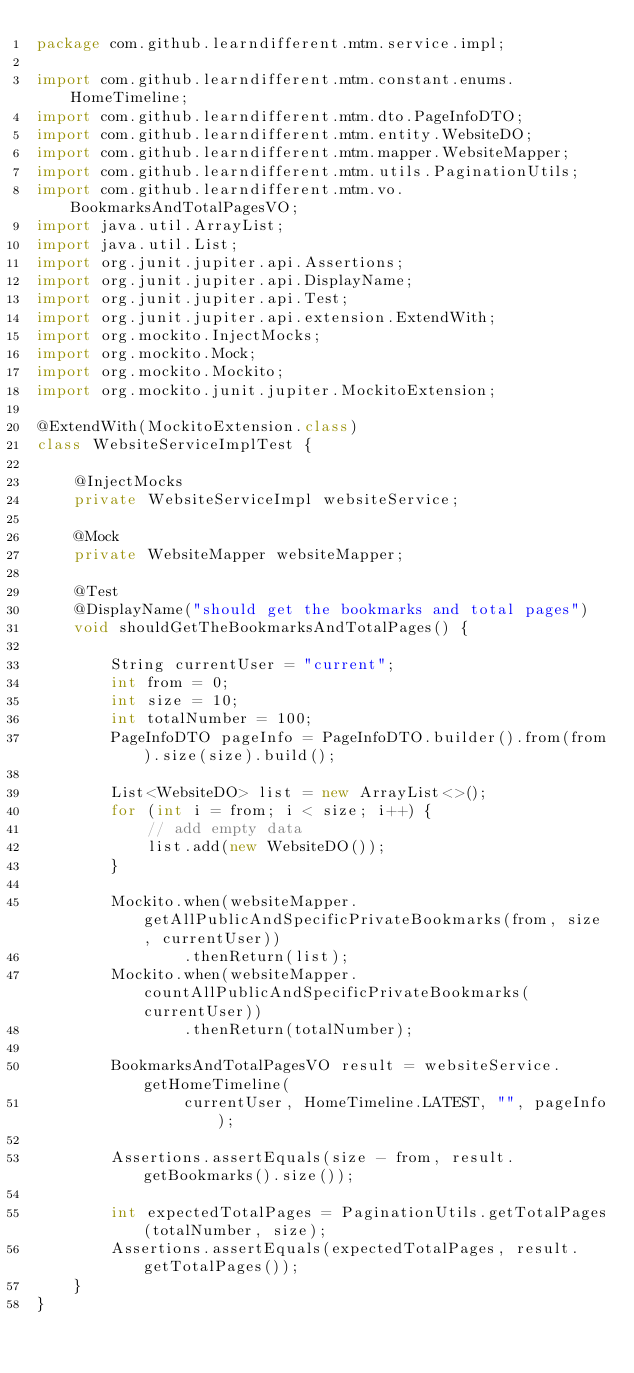Convert code to text. <code><loc_0><loc_0><loc_500><loc_500><_Java_>package com.github.learndifferent.mtm.service.impl;

import com.github.learndifferent.mtm.constant.enums.HomeTimeline;
import com.github.learndifferent.mtm.dto.PageInfoDTO;
import com.github.learndifferent.mtm.entity.WebsiteDO;
import com.github.learndifferent.mtm.mapper.WebsiteMapper;
import com.github.learndifferent.mtm.utils.PaginationUtils;
import com.github.learndifferent.mtm.vo.BookmarksAndTotalPagesVO;
import java.util.ArrayList;
import java.util.List;
import org.junit.jupiter.api.Assertions;
import org.junit.jupiter.api.DisplayName;
import org.junit.jupiter.api.Test;
import org.junit.jupiter.api.extension.ExtendWith;
import org.mockito.InjectMocks;
import org.mockito.Mock;
import org.mockito.Mockito;
import org.mockito.junit.jupiter.MockitoExtension;

@ExtendWith(MockitoExtension.class)
class WebsiteServiceImplTest {

    @InjectMocks
    private WebsiteServiceImpl websiteService;

    @Mock
    private WebsiteMapper websiteMapper;

    @Test
    @DisplayName("should get the bookmarks and total pages")
    void shouldGetTheBookmarksAndTotalPages() {

        String currentUser = "current";
        int from = 0;
        int size = 10;
        int totalNumber = 100;
        PageInfoDTO pageInfo = PageInfoDTO.builder().from(from).size(size).build();

        List<WebsiteDO> list = new ArrayList<>();
        for (int i = from; i < size; i++) {
            // add empty data
            list.add(new WebsiteDO());
        }

        Mockito.when(websiteMapper.getAllPublicAndSpecificPrivateBookmarks(from, size, currentUser))
                .thenReturn(list);
        Mockito.when(websiteMapper.countAllPublicAndSpecificPrivateBookmarks(currentUser))
                .thenReturn(totalNumber);

        BookmarksAndTotalPagesVO result = websiteService.getHomeTimeline(
                currentUser, HomeTimeline.LATEST, "", pageInfo);

        Assertions.assertEquals(size - from, result.getBookmarks().size());

        int expectedTotalPages = PaginationUtils.getTotalPages(totalNumber, size);
        Assertions.assertEquals(expectedTotalPages, result.getTotalPages());
    }
}</code> 